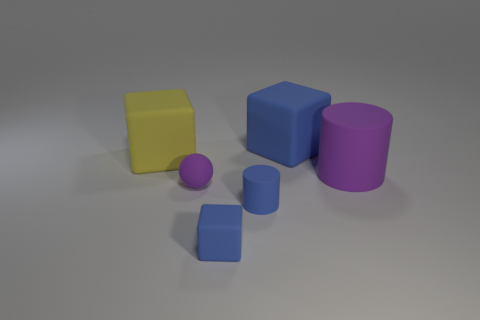What material is the cylinder that is in front of the matte object that is on the right side of the blue object behind the purple cylinder made of? Based on the image, the cylinder in question appears to be a virtual object rendered in 3D software, typically meant to simulate materials like plastic or painted metal. Without additional context, it's not possible to determine the intended material with certainty, but its smooth surface and matte finish suggest it could be a stand-in for something like matte-finished plastic. 